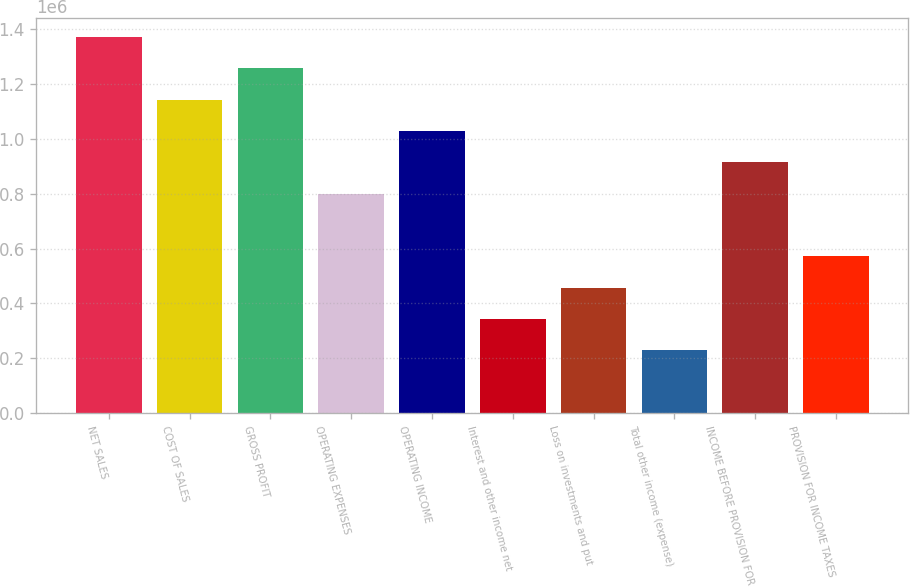<chart> <loc_0><loc_0><loc_500><loc_500><bar_chart><fcel>NET SALES<fcel>COST OF SALES<fcel>GROSS PROFIT<fcel>OPERATING EXPENSES<fcel>OPERATING INCOME<fcel>Interest and other income net<fcel>Loss on investments and put<fcel>Total other income (expense)<fcel>INCOME BEFORE PROVISION FOR<fcel>PROVISION FOR INCOME TAXES<nl><fcel>1.37196e+06<fcel>1.1433e+06<fcel>1.25763e+06<fcel>800310<fcel>1.02897e+06<fcel>342990<fcel>457320<fcel>228661<fcel>914639<fcel>571650<nl></chart> 